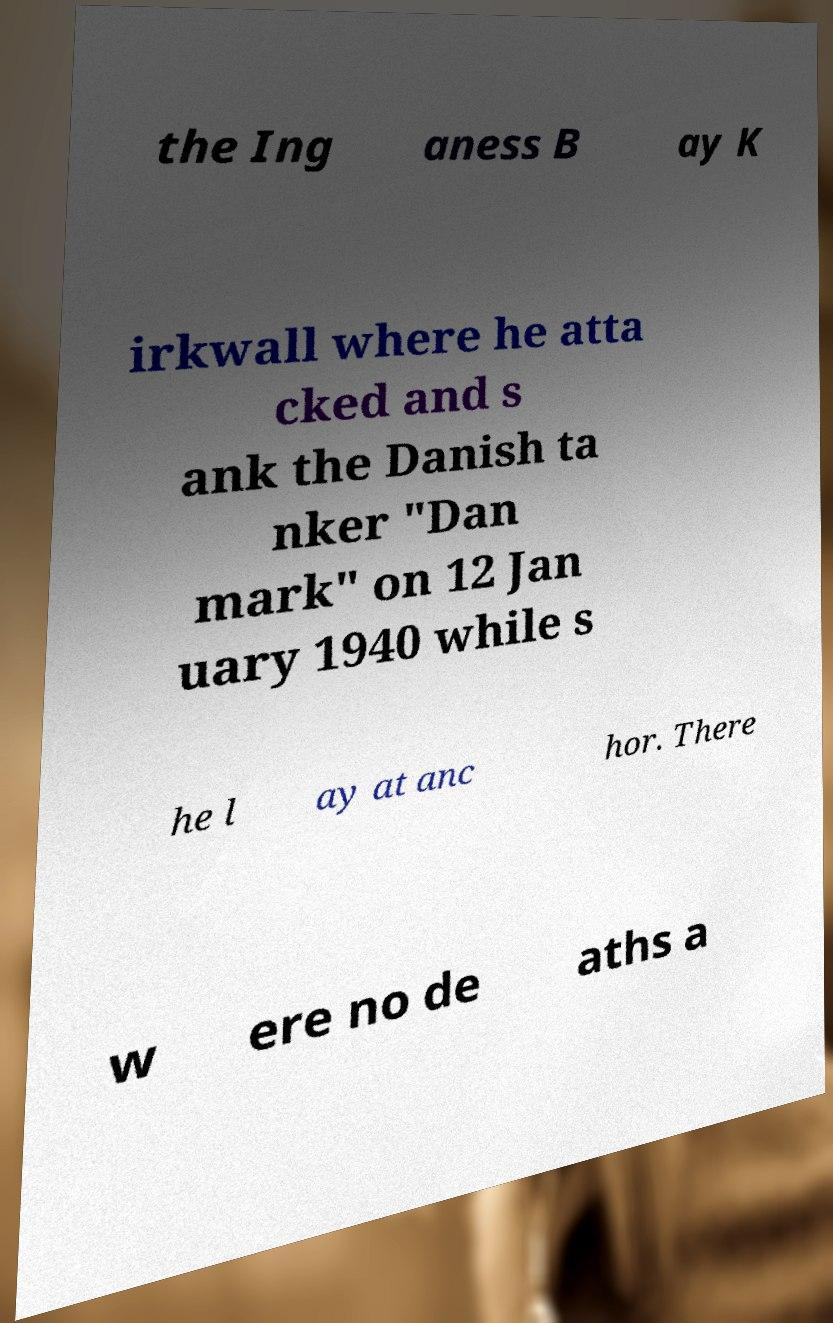Could you assist in decoding the text presented in this image and type it out clearly? the Ing aness B ay K irkwall where he atta cked and s ank the Danish ta nker "Dan mark" on 12 Jan uary 1940 while s he l ay at anc hor. There w ere no de aths a 